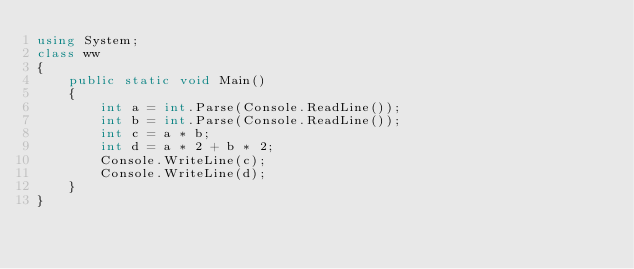Convert code to text. <code><loc_0><loc_0><loc_500><loc_500><_C#_>using System;
class ww
{
    public static void Main()
    {
        int a = int.Parse(Console.ReadLine());
        int b = int.Parse(Console.ReadLine());
        int c = a * b;
        int d = a * 2 + b * 2;
        Console.WriteLine(c);
        Console.WriteLine(d);
    }
}</code> 